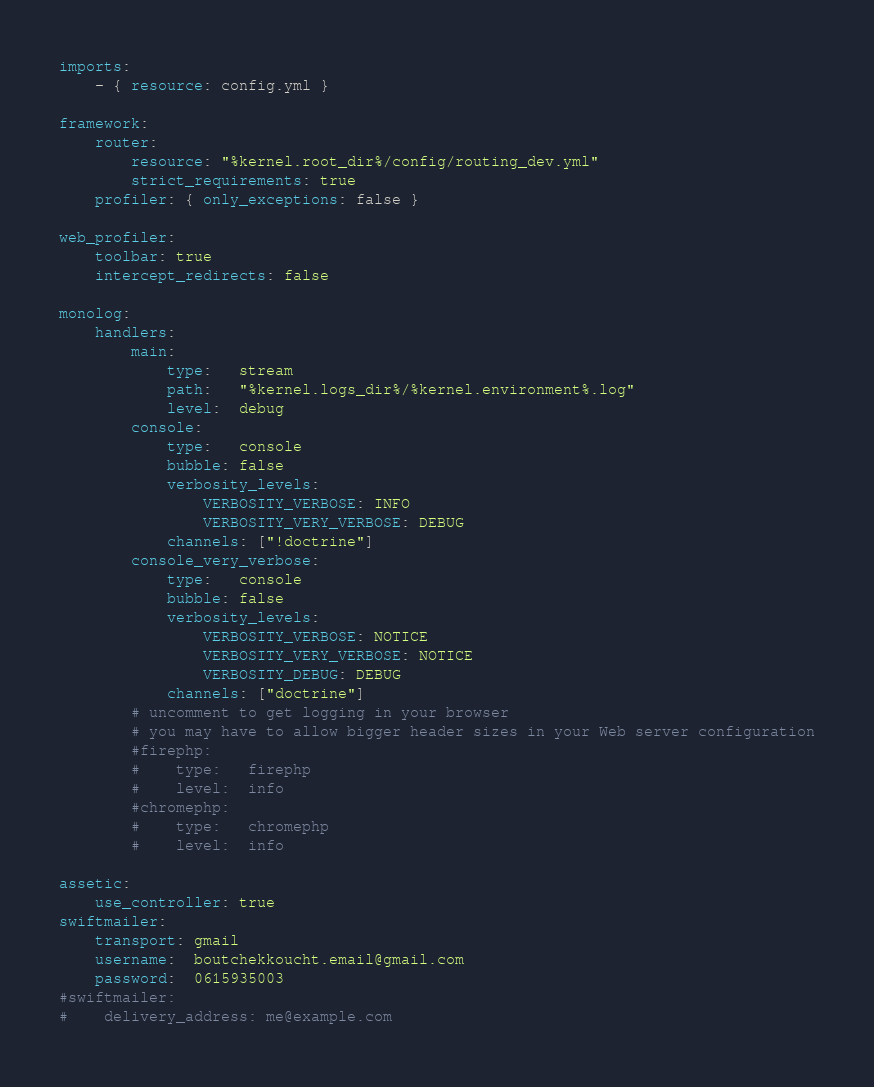Convert code to text. <code><loc_0><loc_0><loc_500><loc_500><_YAML_>imports:
    - { resource: config.yml }

framework:
    router:
        resource: "%kernel.root_dir%/config/routing_dev.yml"
        strict_requirements: true
    profiler: { only_exceptions: false }

web_profiler:
    toolbar: true
    intercept_redirects: false

monolog:
    handlers:
        main:
            type:   stream
            path:   "%kernel.logs_dir%/%kernel.environment%.log"
            level:  debug
        console:
            type:   console
            bubble: false
            verbosity_levels:
                VERBOSITY_VERBOSE: INFO
                VERBOSITY_VERY_VERBOSE: DEBUG
            channels: ["!doctrine"]
        console_very_verbose:
            type:   console
            bubble: false
            verbosity_levels:
                VERBOSITY_VERBOSE: NOTICE
                VERBOSITY_VERY_VERBOSE: NOTICE
                VERBOSITY_DEBUG: DEBUG
            channels: ["doctrine"]
        # uncomment to get logging in your browser
        # you may have to allow bigger header sizes in your Web server configuration
        #firephp:
        #    type:   firephp
        #    level:  info
        #chromephp:
        #    type:   chromephp
        #    level:  info

assetic:
    use_controller: true
swiftmailer:
    transport: gmail
    username:  boutchekkoucht.email@gmail.com
    password:  0615935003
#swiftmailer:
#    delivery_address: me@example.com
</code> 